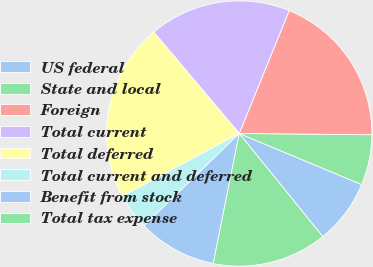Convert chart. <chart><loc_0><loc_0><loc_500><loc_500><pie_chart><fcel>US federal<fcel>State and local<fcel>Foreign<fcel>Total current<fcel>Total deferred<fcel>Total current and deferred<fcel>Benefit from stock<fcel>Total tax expense<nl><fcel>7.87%<fcel>6.14%<fcel>19.01%<fcel>17.29%<fcel>21.7%<fcel>4.41%<fcel>9.6%<fcel>13.98%<nl></chart> 